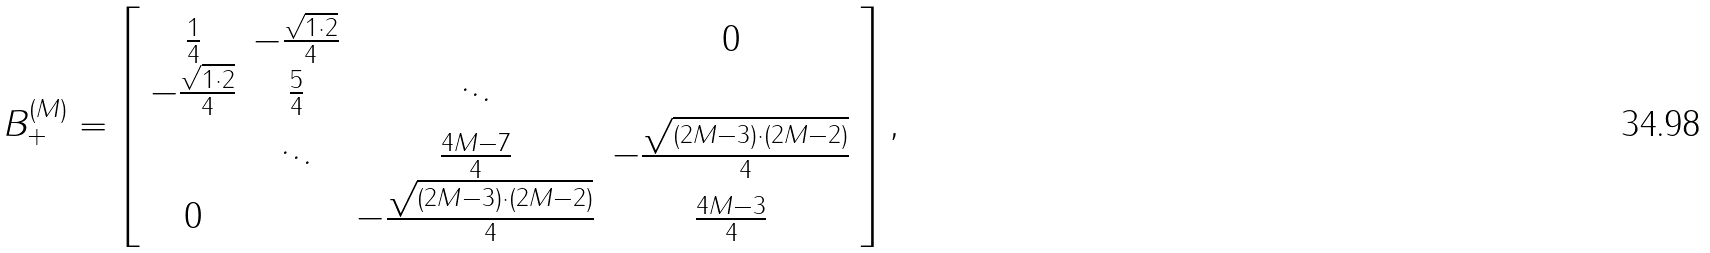Convert formula to latex. <formula><loc_0><loc_0><loc_500><loc_500>B ^ { ( M ) } _ { + } = \left [ \begin{array} { c c c c c c c } \frac { 1 } { 4 } & - \frac { \sqrt { 1 \cdot 2 } } { 4 } & & 0 \\ - \frac { \sqrt { 1 \cdot 2 } } { 4 } & \frac { 5 } { 4 } & \ddots & \\ & \ddots & \frac { 4 M - 7 } { 4 } & - \frac { \sqrt { ( 2 M - 3 ) \cdot ( 2 M - 2 ) } } { 4 } \\ 0 & & - \frac { \sqrt { ( 2 M - 3 ) \cdot ( 2 M - 2 ) } } { 4 } & \frac { 4 M - 3 } { 4 } \end{array} \right ] ,</formula> 